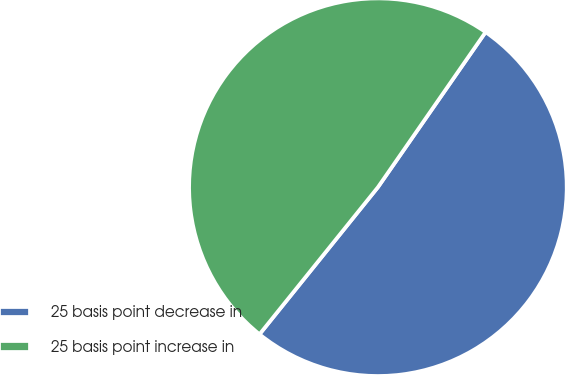Convert chart to OTSL. <chart><loc_0><loc_0><loc_500><loc_500><pie_chart><fcel>25 basis point decrease in<fcel>25 basis point increase in<nl><fcel>51.13%<fcel>48.87%<nl></chart> 